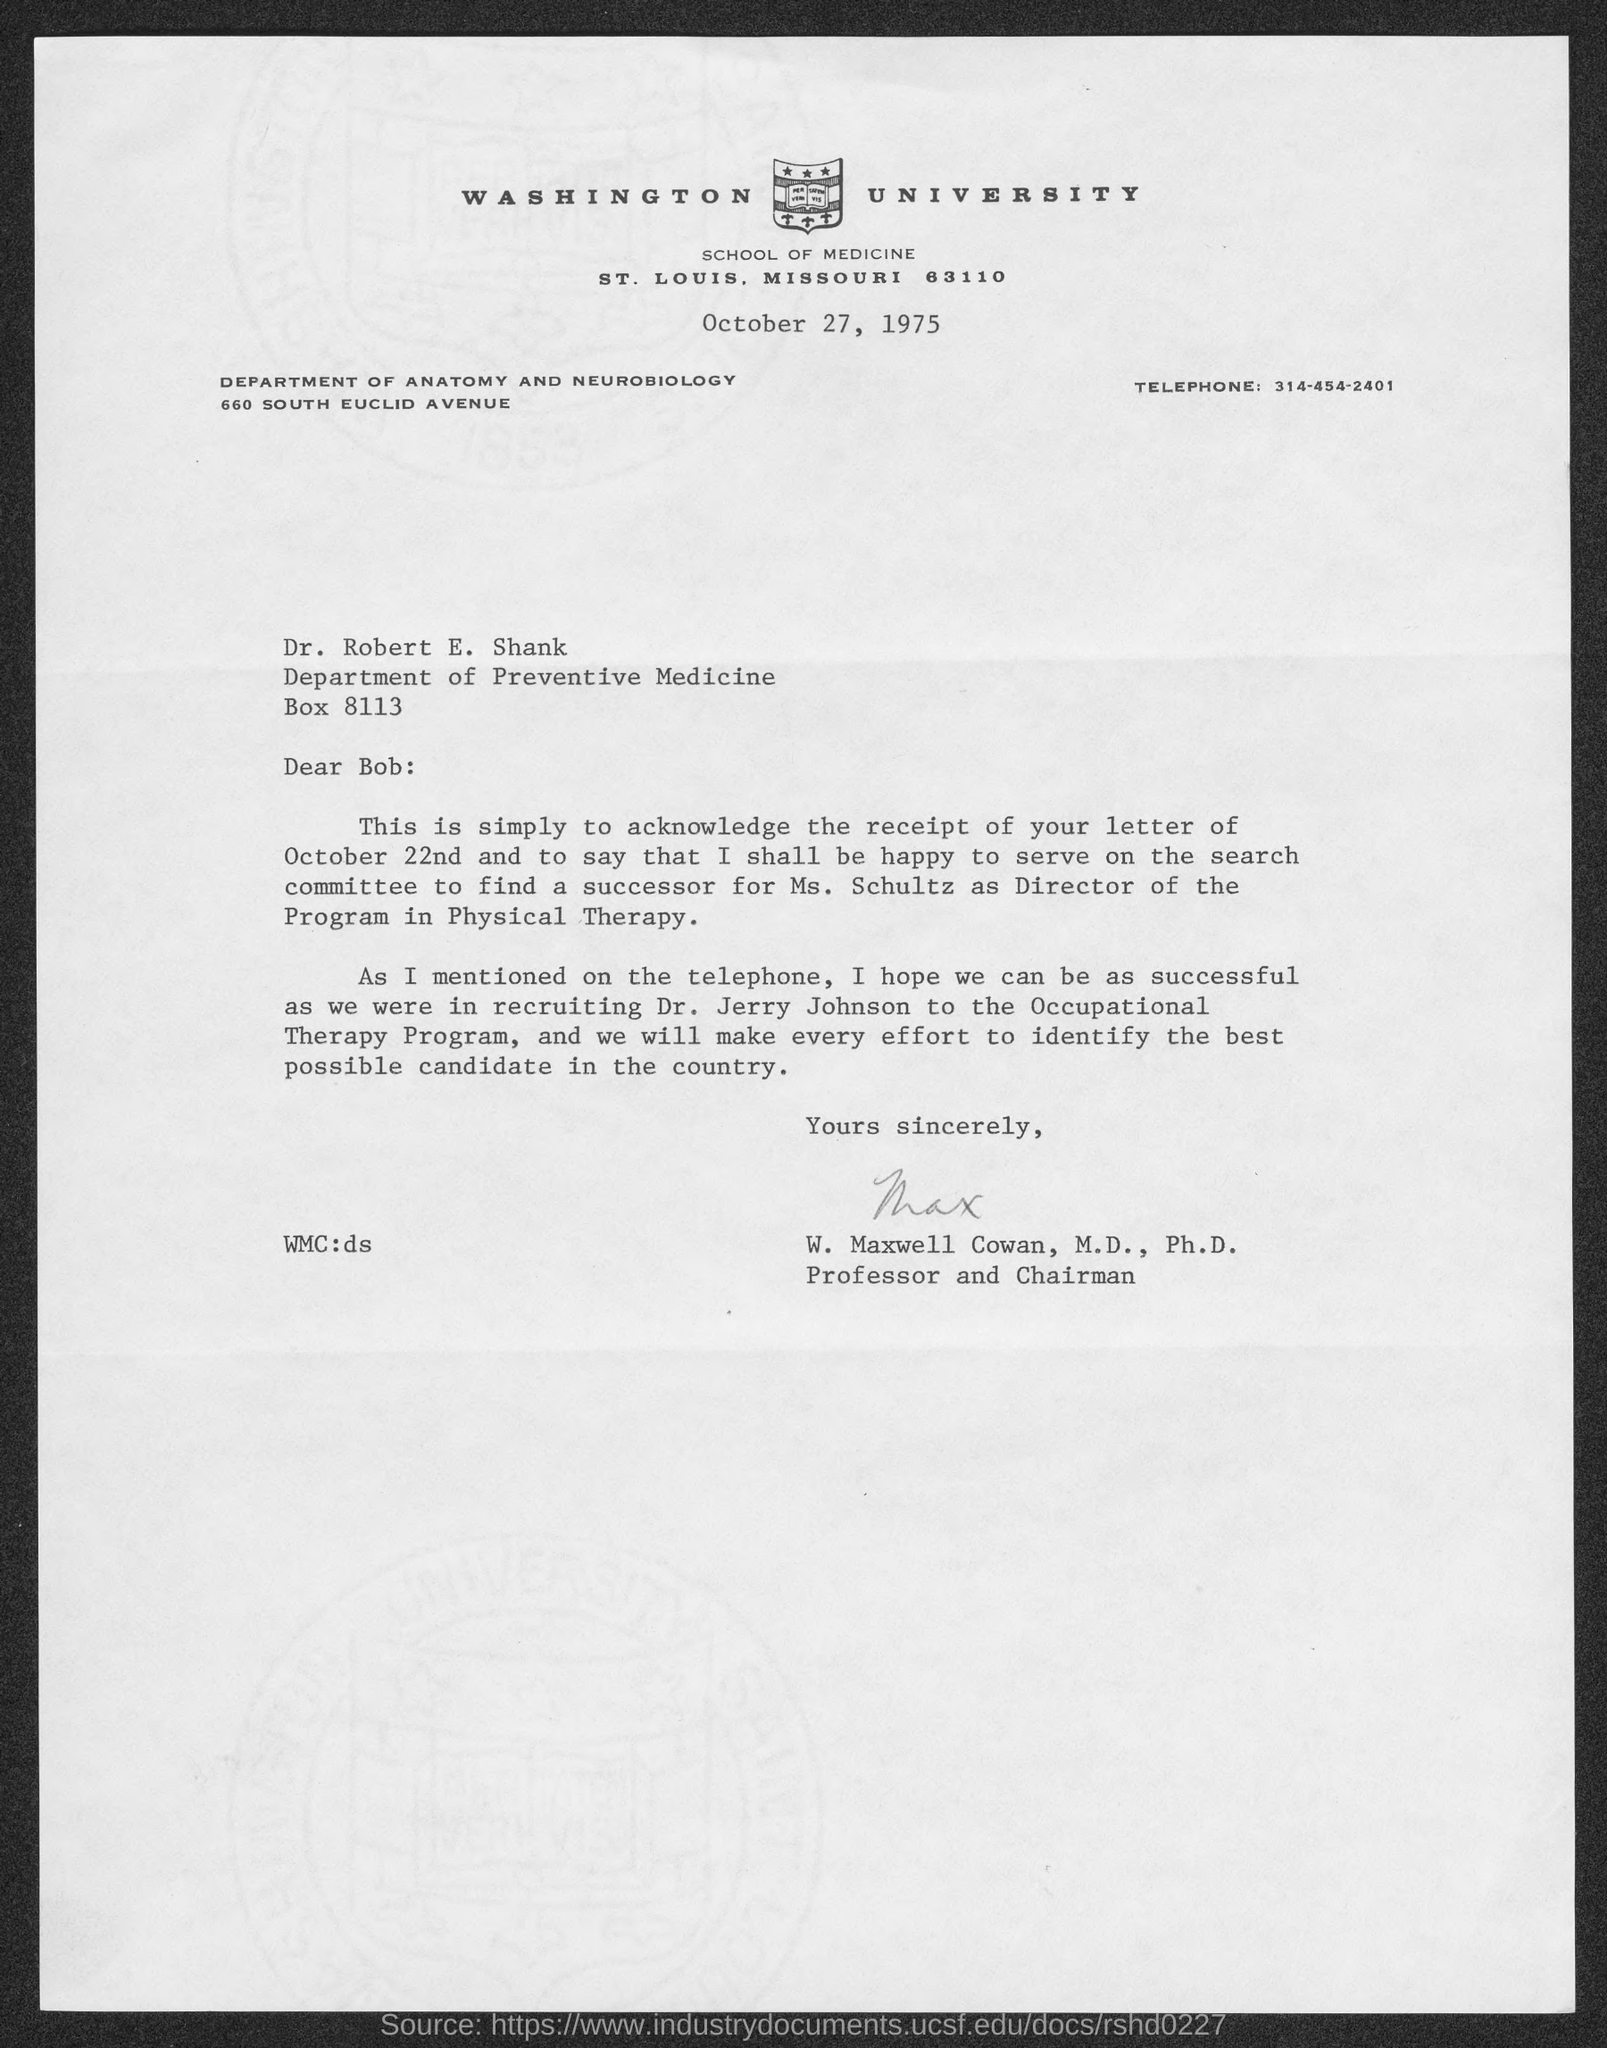Which is the department of Dr. Robert?
Offer a terse response. Preventive medicine. Whose successor needs to be find?
Provide a short and direct response. Ms. Schultz. Who is the sender of the letter?
Keep it short and to the point. W. Maxwell Cowan, M.D., Ph.D. 